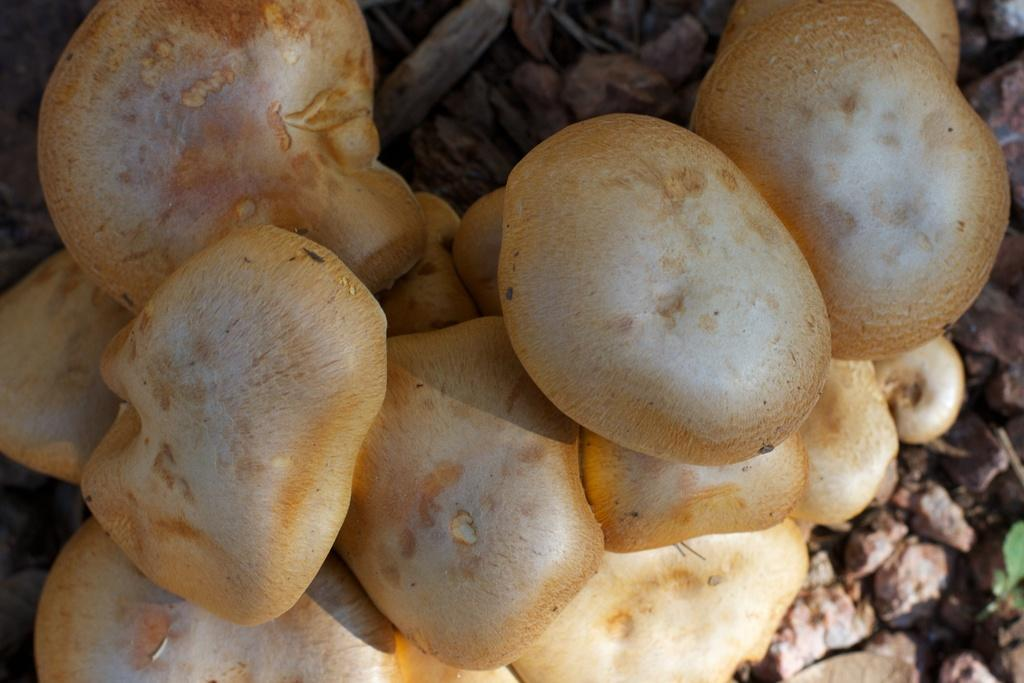What type of vegetation is in the foreground of the image? There are mushrooms in the foreground of the image. What can be seen in the background of the image? There are stones and dry grass in the background of the image. Can you tell me how many grapes are on the mushrooms in the image? There are no grapes present in the image; it features mushrooms and stones in the background. What type of animal is talking to the mushrooms in the image? There are no animals or talking in the image; it only shows mushrooms, stones, and dry grass. 